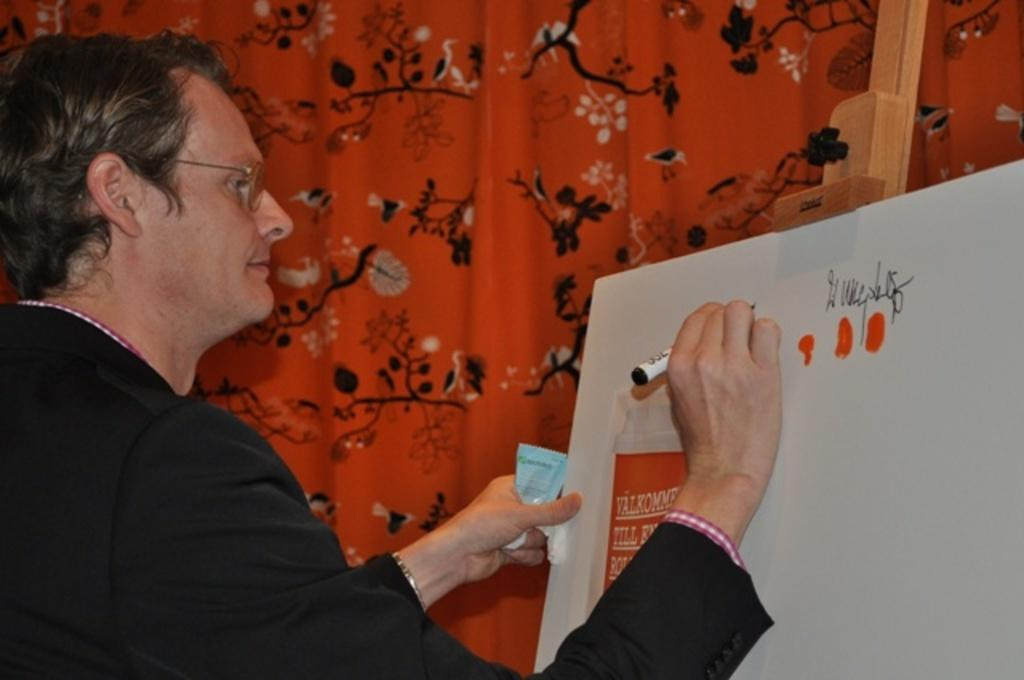What is the main subject in the foreground of the picture? There is a person in the foreground of the picture. What is the person wearing? The person is wearing a black jacket. What is the person doing in the image? The person is writing on a whiteboard. What can be seen on the whiteboard? There is a paper on the whiteboard, and there is text on the whiteboard. What is visible in the background of the image? There is a curtain in the background of the image. How does the person react to the mist in the image? There is no mist present in the image, so the person's reaction cannot be determined. 